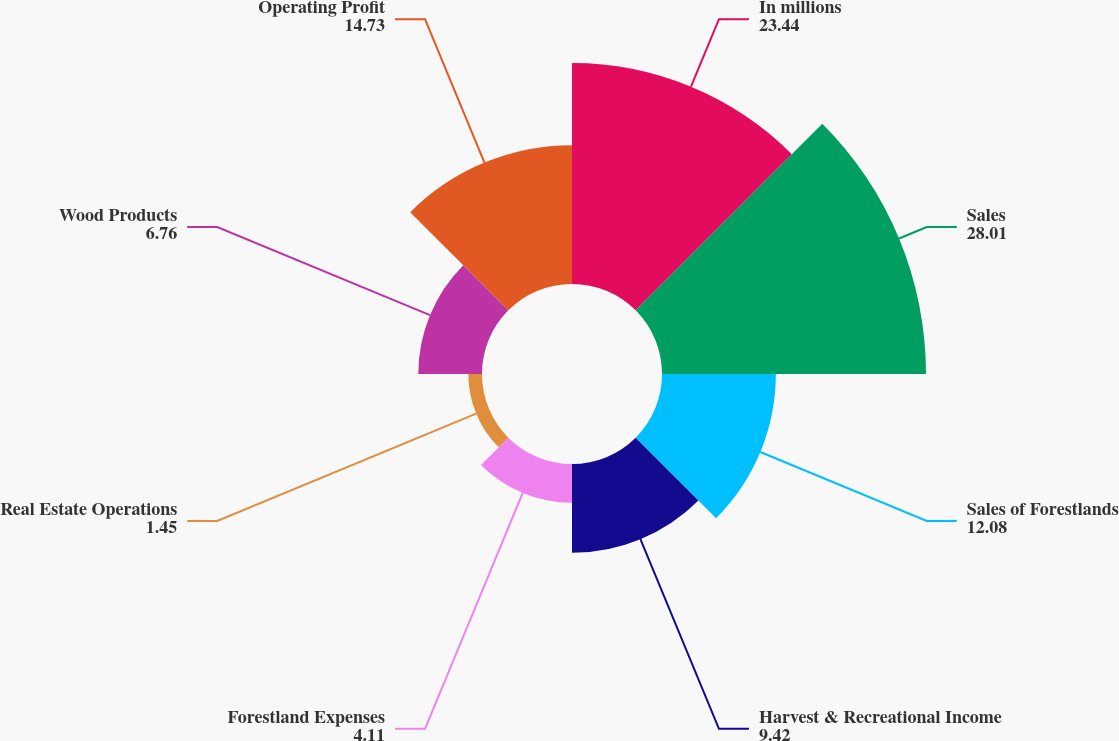<chart> <loc_0><loc_0><loc_500><loc_500><pie_chart><fcel>In millions<fcel>Sales<fcel>Sales of Forestlands<fcel>Harvest & Recreational Income<fcel>Forestland Expenses<fcel>Real Estate Operations<fcel>Wood Products<fcel>Operating Profit<nl><fcel>23.44%<fcel>28.01%<fcel>12.08%<fcel>9.42%<fcel>4.11%<fcel>1.45%<fcel>6.76%<fcel>14.73%<nl></chart> 